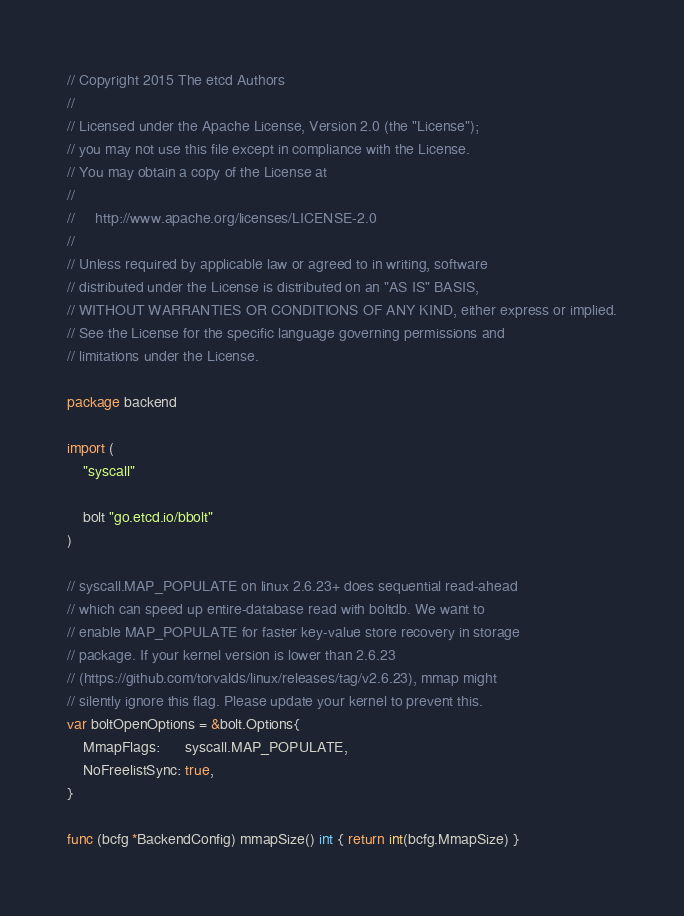Convert code to text. <code><loc_0><loc_0><loc_500><loc_500><_Go_>// Copyright 2015 The etcd Authors
//
// Licensed under the Apache License, Version 2.0 (the "License");
// you may not use this file except in compliance with the License.
// You may obtain a copy of the License at
//
//     http://www.apache.org/licenses/LICENSE-2.0
//
// Unless required by applicable law or agreed to in writing, software
// distributed under the License is distributed on an "AS IS" BASIS,
// WITHOUT WARRANTIES OR CONDITIONS OF ANY KIND, either express or implied.
// See the License for the specific language governing permissions and
// limitations under the License.

package backend

import (
	"syscall"

	bolt "go.etcd.io/bbolt"
)

// syscall.MAP_POPULATE on linux 2.6.23+ does sequential read-ahead
// which can speed up entire-database read with boltdb. We want to
// enable MAP_POPULATE for faster key-value store recovery in storage
// package. If your kernel version is lower than 2.6.23
// (https://github.com/torvalds/linux/releases/tag/v2.6.23), mmap might
// silently ignore this flag. Please update your kernel to prevent this.
var boltOpenOptions = &bolt.Options{
	MmapFlags:      syscall.MAP_POPULATE,
	NoFreelistSync: true,
}

func (bcfg *BackendConfig) mmapSize() int { return int(bcfg.MmapSize) }
</code> 